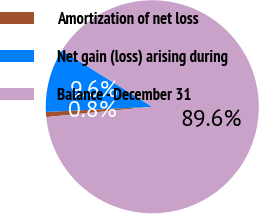Convert chart to OTSL. <chart><loc_0><loc_0><loc_500><loc_500><pie_chart><fcel>Amortization of net loss<fcel>Net gain (loss) arising during<fcel>Balance - December 31<nl><fcel>0.77%<fcel>9.65%<fcel>89.58%<nl></chart> 